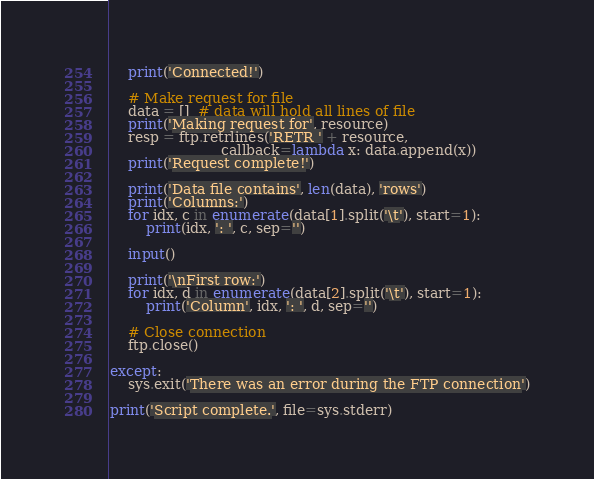<code> <loc_0><loc_0><loc_500><loc_500><_Python_>    print('Connected!')

    # Make request for file
    data = []  # data will hold all lines of file
    print('Making request for', resource)
    resp = ftp.retrlines('RETR ' + resource,
                         callback=lambda x: data.append(x))
    print('Request complete!')

    print('Data file contains', len(data), 'rows')
    print('Columns:')
    for idx, c in enumerate(data[1].split('\t'), start=1):
        print(idx, ': ', c, sep='')

    input()

    print('\nFirst row:')
    for idx, d in enumerate(data[2].split('\t'), start=1):
        print('Column', idx, ': ', d, sep='')

    # Close connection
    ftp.close()

except:
    sys.exit('There was an error during the FTP connection')

print('Script complete.', file=sys.stderr)
</code> 